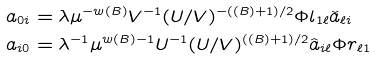<formula> <loc_0><loc_0><loc_500><loc_500>a _ { 0 i } & = \lambda \mu ^ { - w ( B ) } V ^ { - 1 } ( U / V ) ^ { - ( \sl ( B ) + 1 ) / 2 } \Phi l _ { 1 \ell } \check { a } _ { \ell i } \\ a _ { i 0 } & = \lambda ^ { - 1 } \mu ^ { w ( B ) - 1 } U ^ { - 1 } ( U / V ) ^ { ( \sl ( B ) + 1 ) / 2 } \hat { a } _ { i \ell } \Phi r _ { \ell 1 }</formula> 